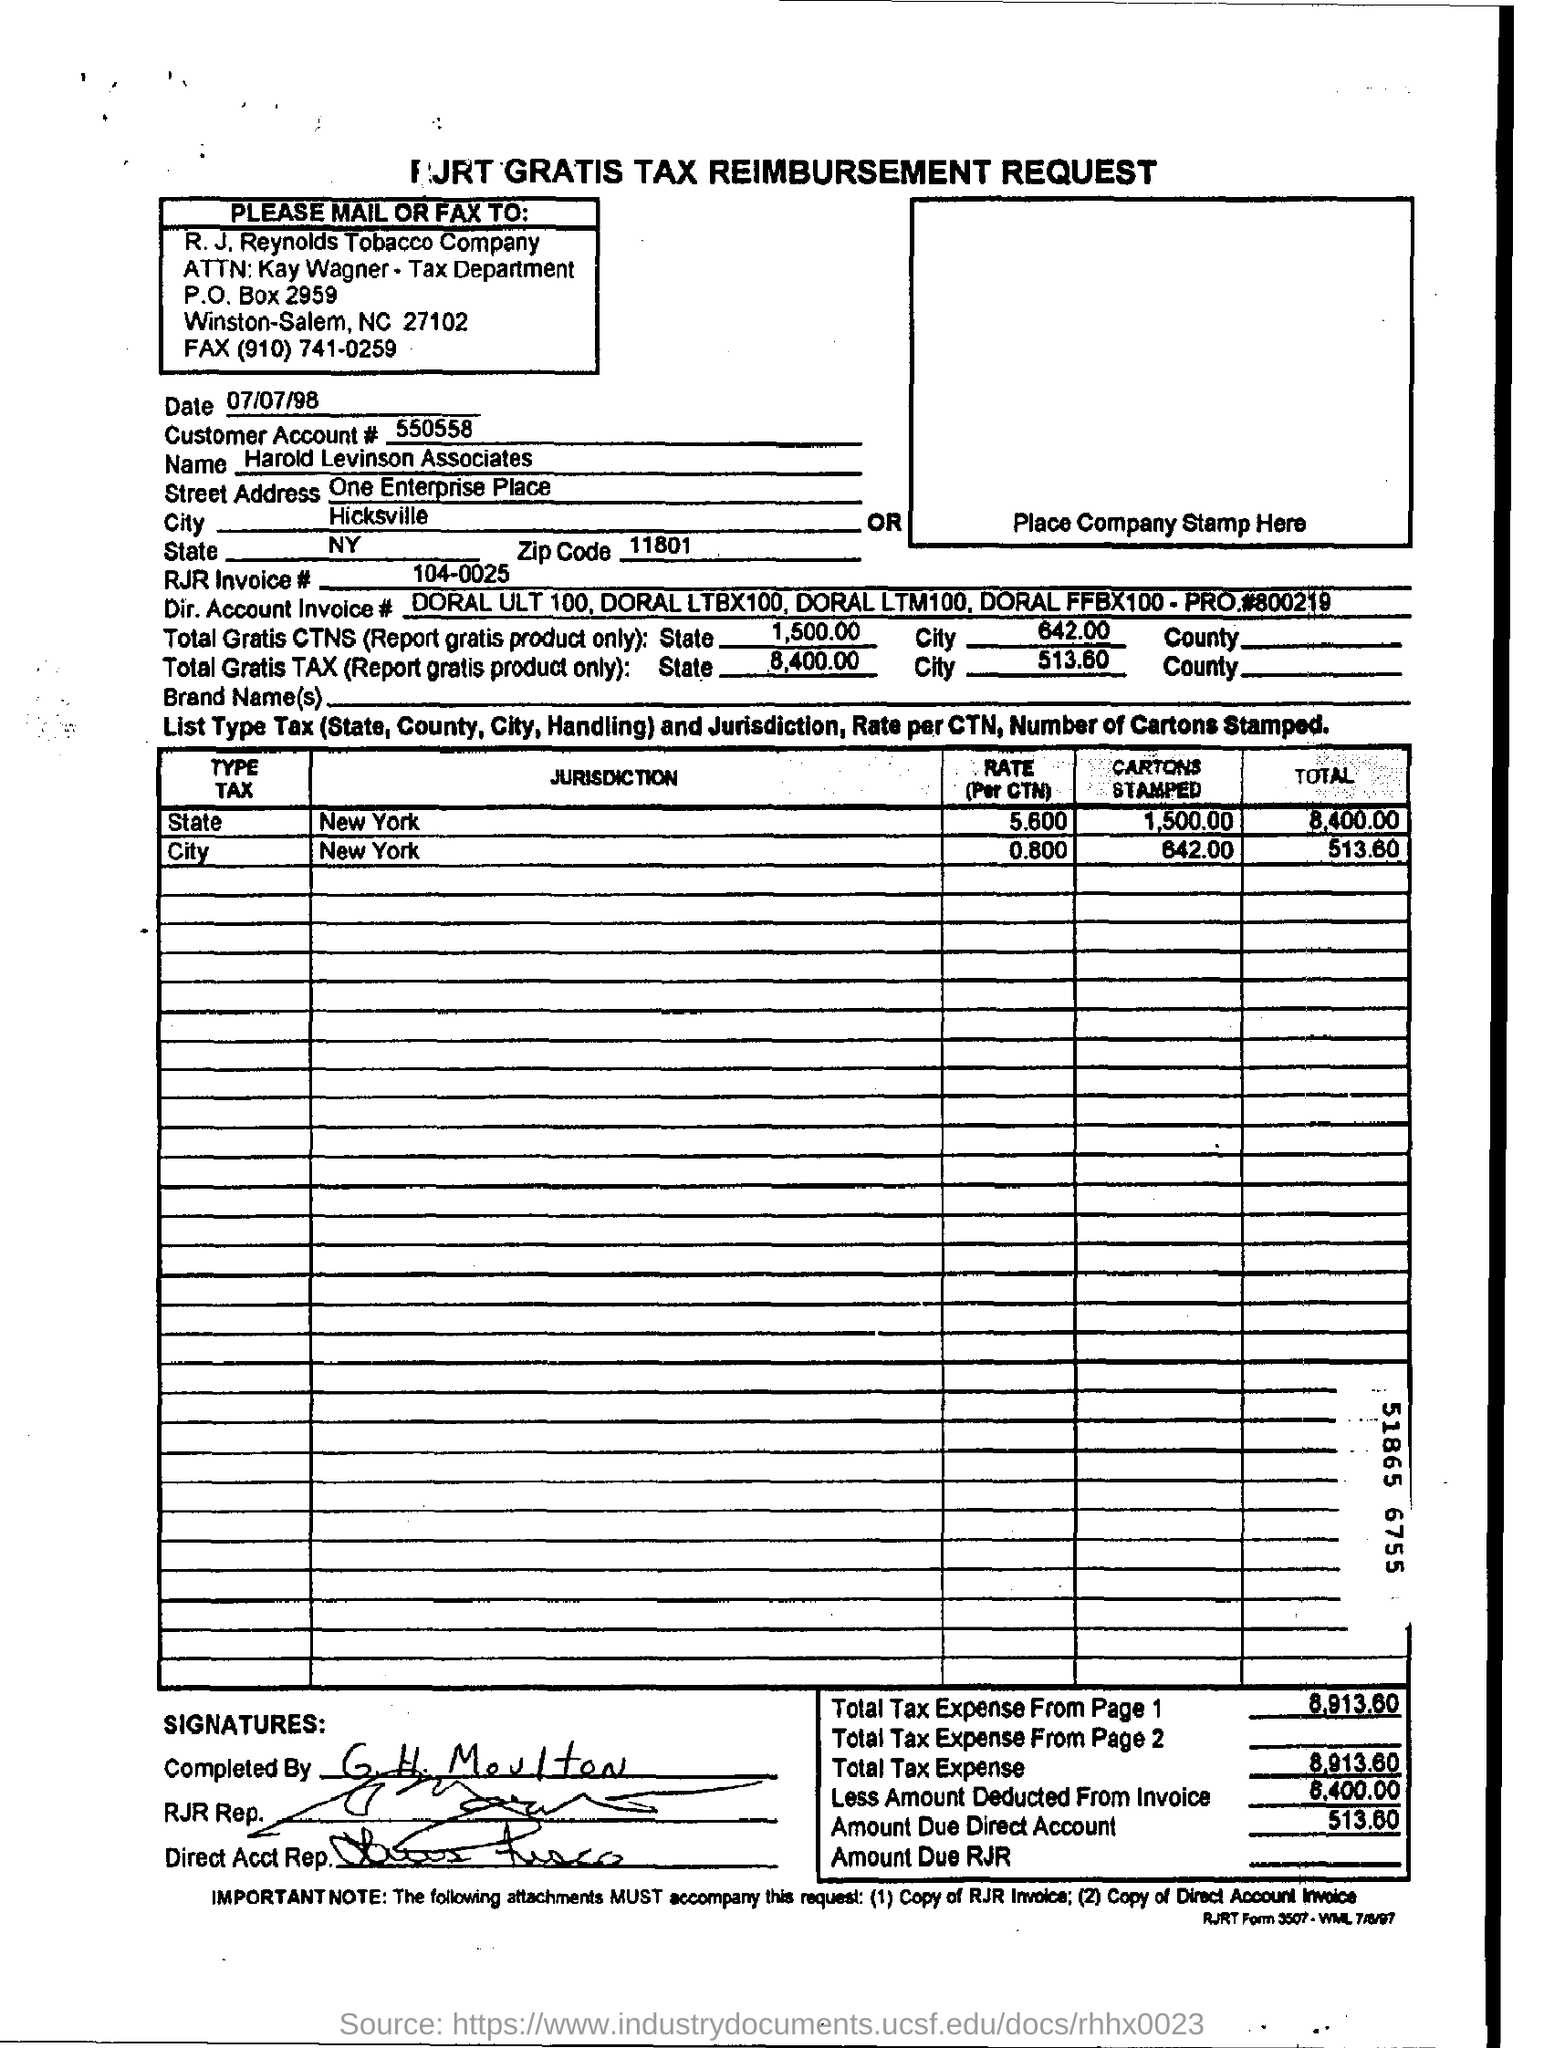Identify some key points in this picture. The abbreviation "RJR Invoice" is a reference to a specific invoice number, which is 104-0025. The zip code is 11801. The customer account number is 550558... One Enterprise Place is the street address of a location. The customer's name is Harold Levinson Associates. 